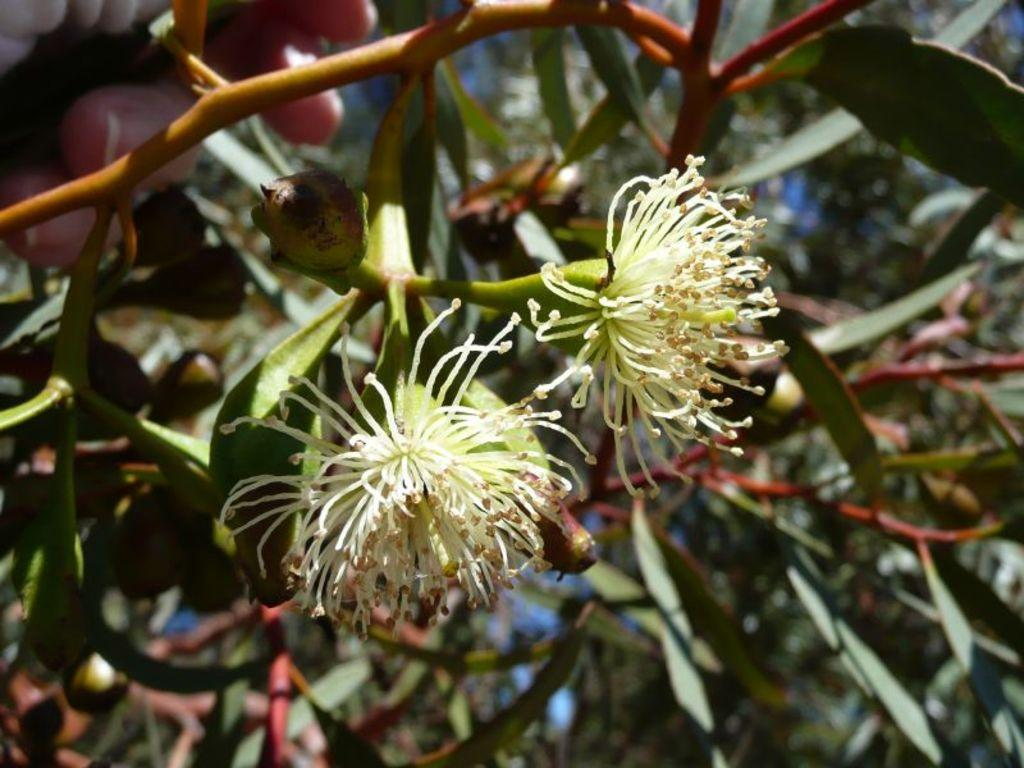What is located in the front of the image? There are plants in the front of the image. Where can a person's hand be seen in the image? A person's hand is visible in the top left of the image. What can be seen in the background of the image? There are leaves in the background of the image. What grade does the creature in the image receive for its performance? There is no creature present in the image, so it cannot receive a grade for its performance. How does the person in the image say good-bye to the creature? There is no creature present in the image, so the person cannot say good-bye to it. 